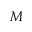<formula> <loc_0><loc_0><loc_500><loc_500>M</formula> 